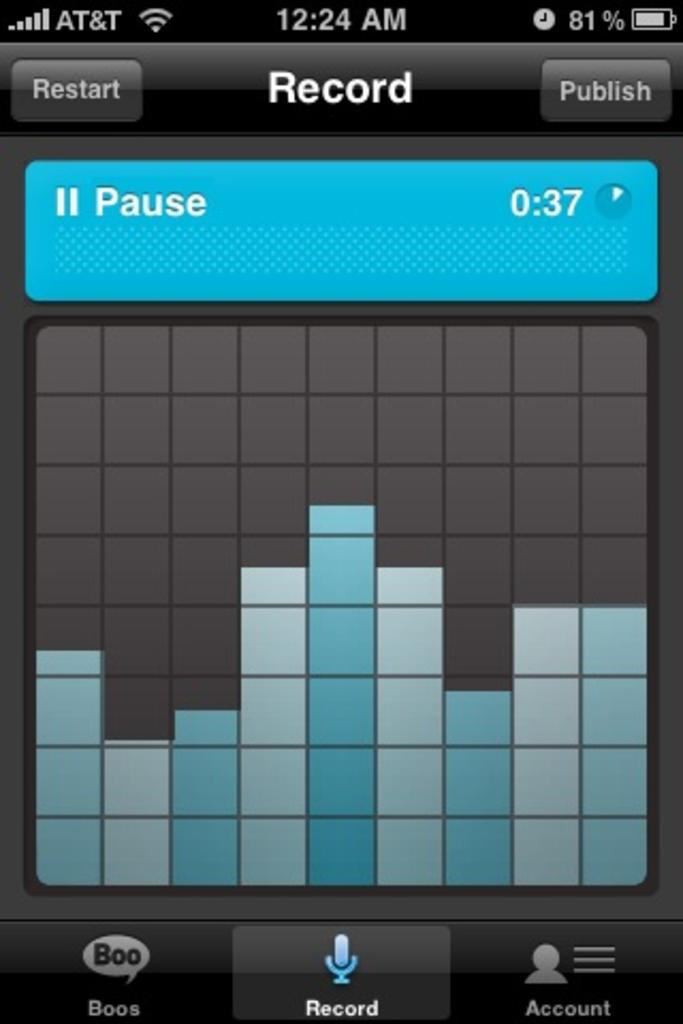Provide a one-sentence caption for the provided image. At 12:24am game has been paused at 0:37. 